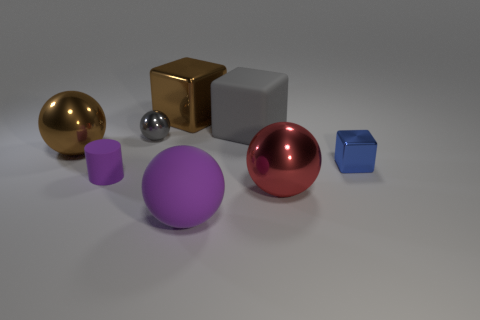Is there a metal thing that has the same color as the cylinder?
Provide a short and direct response. No. There is a metal cube that is the same size as the gray shiny thing; what is its color?
Your answer should be compact. Blue. There is a purple thing that is to the left of the large thing in front of the big metallic sphere in front of the small rubber cylinder; what is it made of?
Provide a succinct answer. Rubber. There is a cylinder; does it have the same color as the metal sphere that is to the right of the brown metal block?
Your answer should be compact. No. How many objects are either metal blocks on the left side of the big gray block or brown objects that are in front of the gray metal thing?
Make the answer very short. 2. What is the shape of the brown metallic object that is in front of the shiny cube behind the big brown metal ball?
Provide a short and direct response. Sphere. Is there a tiny blue thing made of the same material as the big gray cube?
Your answer should be very brief. No. What is the color of the other tiny thing that is the same shape as the gray matte thing?
Your answer should be very brief. Blue. Is the number of gray shiny balls that are to the left of the tiny rubber thing less than the number of purple rubber objects that are behind the big gray thing?
Give a very brief answer. No. How many other objects are there of the same shape as the blue metallic thing?
Offer a very short reply. 2. 